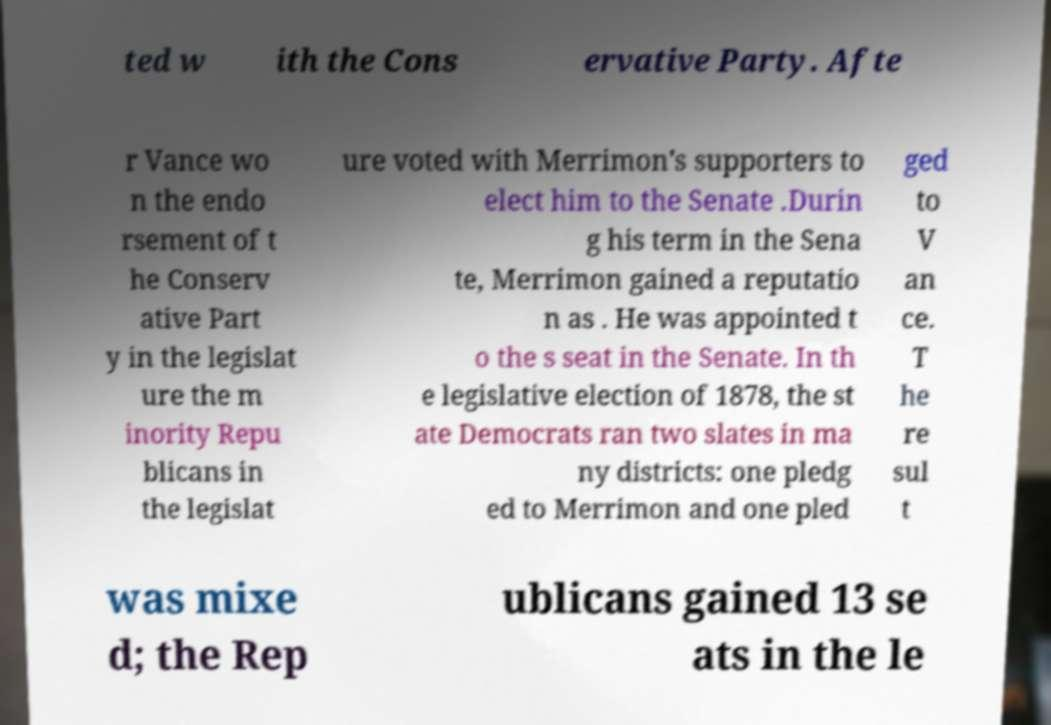Please read and relay the text visible in this image. What does it say? ted w ith the Cons ervative Party. Afte r Vance wo n the endo rsement of t he Conserv ative Part y in the legislat ure the m inority Repu blicans in the legislat ure voted with Merrimon's supporters to elect him to the Senate .Durin g his term in the Sena te, Merrimon gained a reputatio n as . He was appointed t o the s seat in the Senate. In th e legislative election of 1878, the st ate Democrats ran two slates in ma ny districts: one pledg ed to Merrimon and one pled ged to V an ce. T he re sul t was mixe d; the Rep ublicans gained 13 se ats in the le 